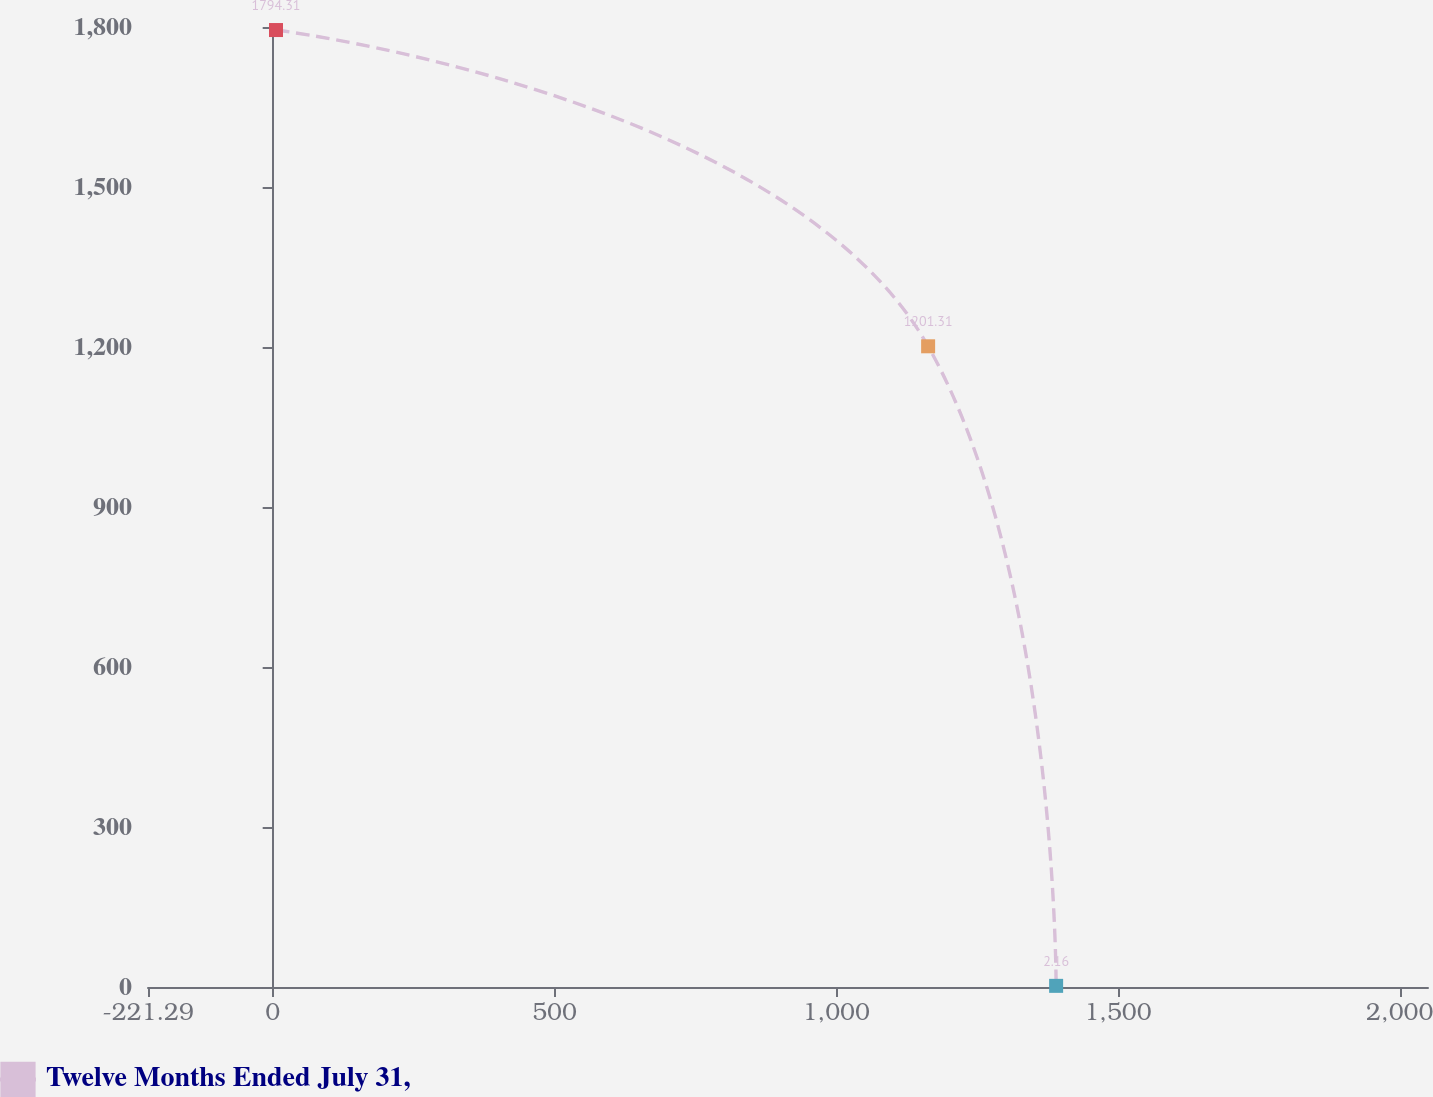<chart> <loc_0><loc_0><loc_500><loc_500><line_chart><ecel><fcel>Twelve Months Ended July 31,<nl><fcel>5.86<fcel>1794.31<nl><fcel>1163.13<fcel>1201.31<nl><fcel>1390.28<fcel>2.16<nl><fcel>2277.36<fcel>1380.52<nl></chart> 